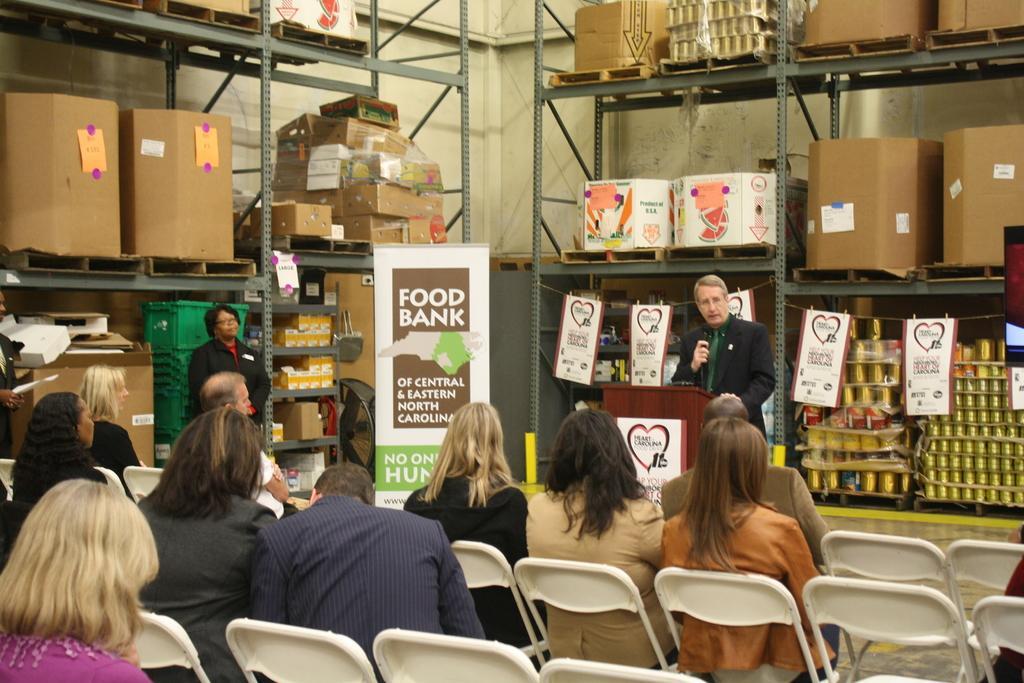Could you give a brief overview of what you see in this image? This image is taken inside a room. There are few people in this room. In the left side of the image few people are sitting on the chairs. In the right side of the image there are few empty chairs and a rack with shelves and there are cardboard boxes and few things in it. In the background there are few racks with shelves and many things in and there is a wall, banner with text on it and a man is standing near the podium holding a mic in his hand. 